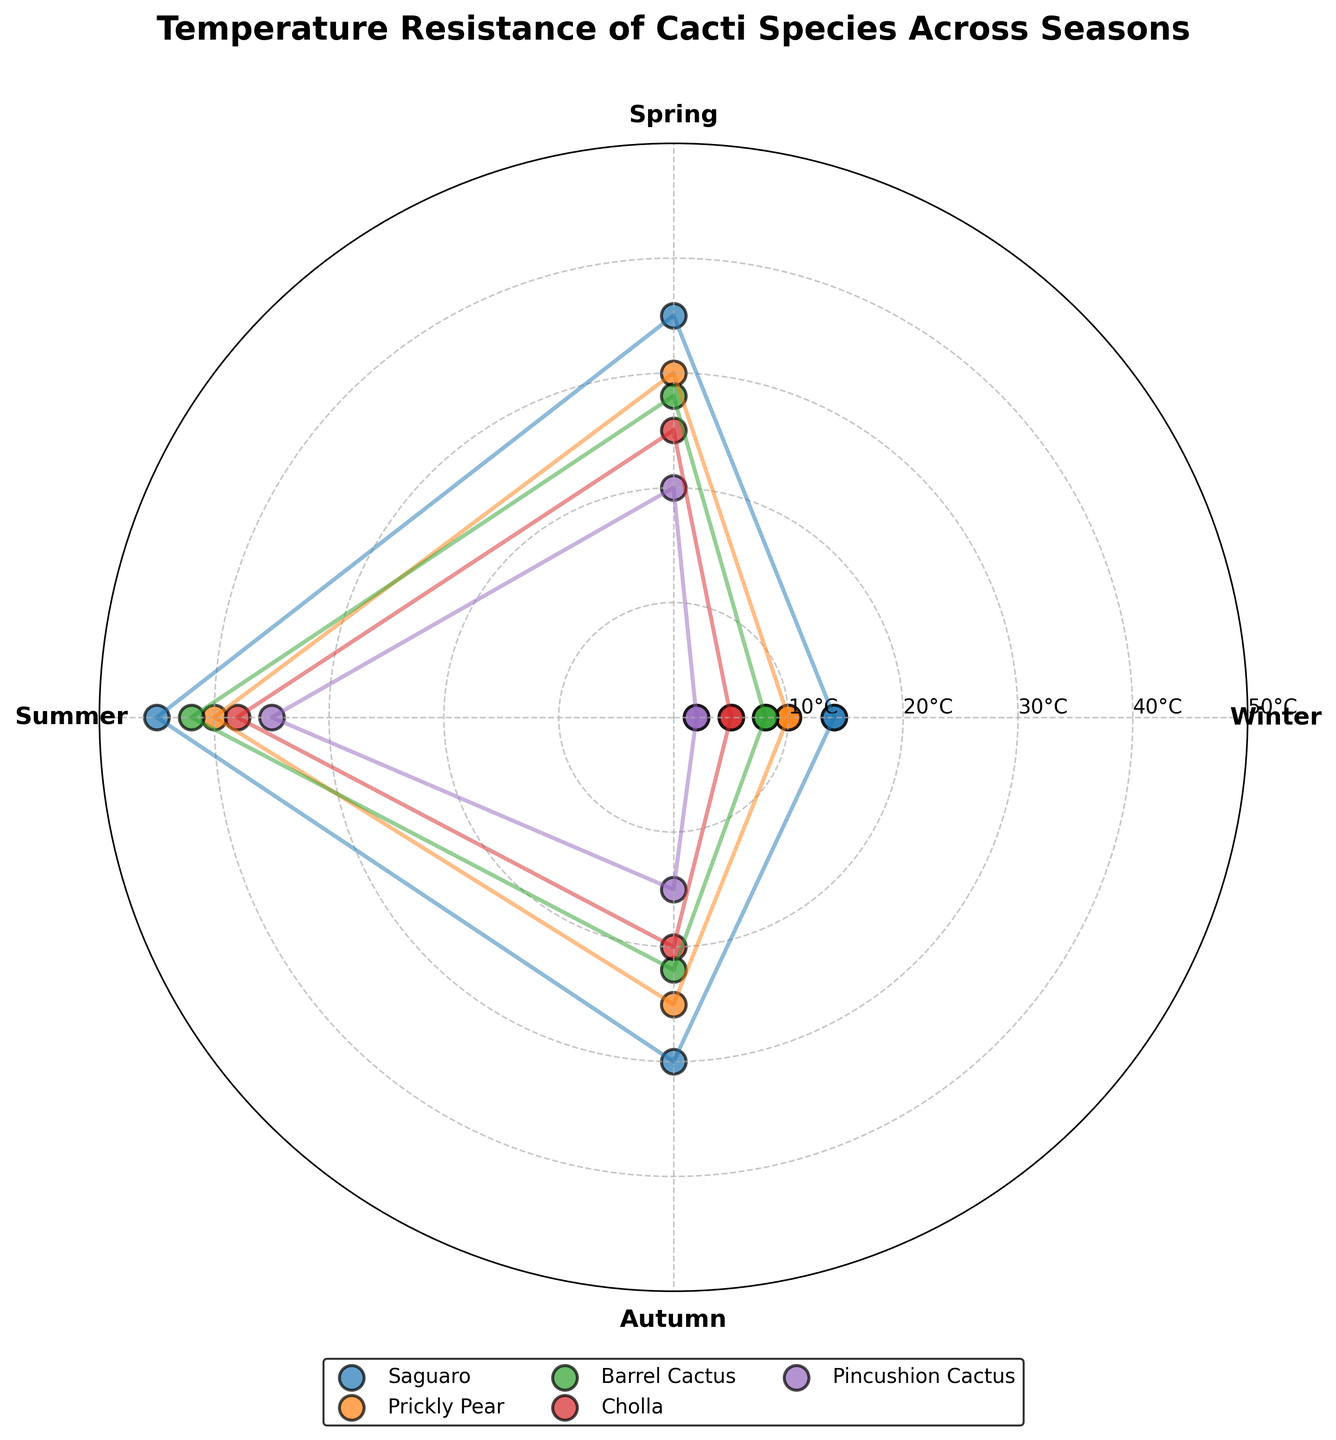What's the title of the figure? The title of the figure is usually found at the top and provides a summary of the visualization's purpose or content. This title specifically should summarize the comparison of temperature resistance for various cacti species across different seasons.
Answer: Temperature Resistance of Cacti Species Across Seasons How many species of cacti are represented in the figure? Count the different species listed in the legend, as each species is represented by a unique color and marker type in the scatter plot.
Answer: 5 Which species of cactus has the highest temperature resistance in the summer? Look for the data points corresponding to the summer season and identify the one with the highest resistance value. The legend can help in identifying the species related to that data point.
Answer: Saguaro What is the temperature range for the Prickly Pear across all seasons? Note the highest and lowest temperature resistance values for Prickly Pear over all seasons by looking at the respective data points. Calculate the range by subtracting the lowest value from the highest value. Prickly Pear's values are 10, 30, 40, and 25, so the range is 40 - 10.
Answer: 30 Comparing Autumn values, which cactus species has the lowest temperature resistance? Inspect the data points for the Autumn season and find the lowest value. Then, use the legend to identify the corresponding species.
Answer: Pincushion Cactus Is there any species that has the same temperature resistance in Winter and Autumn? Look for matching data points in both Winter and Autumn seasons. Compare each species' values in these seasons.
Answer: No What is the difference in temperature resistance between Saguaro and Cholla during Spring? Retrieve the temperature resistance values for both Saguaro and Cholla in Spring, then subtract Cholla’s value from Saguaro’s value. Saguaro's value is 35 and Cholla's value is 25.
Answer: 10 Which two species have the closest temperature resistance values in Winter and what are those values? Compare the Winter data points for all species and determine the two closest values.
Answer: Barrel Cactus and Prickly Pear (8 and 10) On average, which season shows the highest temperature resistance across all species? Calculate the average temperature resistance for each season by summing the resistance values for all species within that season and dividing by the number of species. Determine which season has the highest average value.
Answer: Summer In the chart, for which two species is the difference in temperature resistance exactly 10°C in any season? Compare the temperature resistance values for all species across each season and identify any instances where the difference is exactly 10°C.
Answer: Prickly Pear and Barrel Cactus in Autumn (25 and 22) 